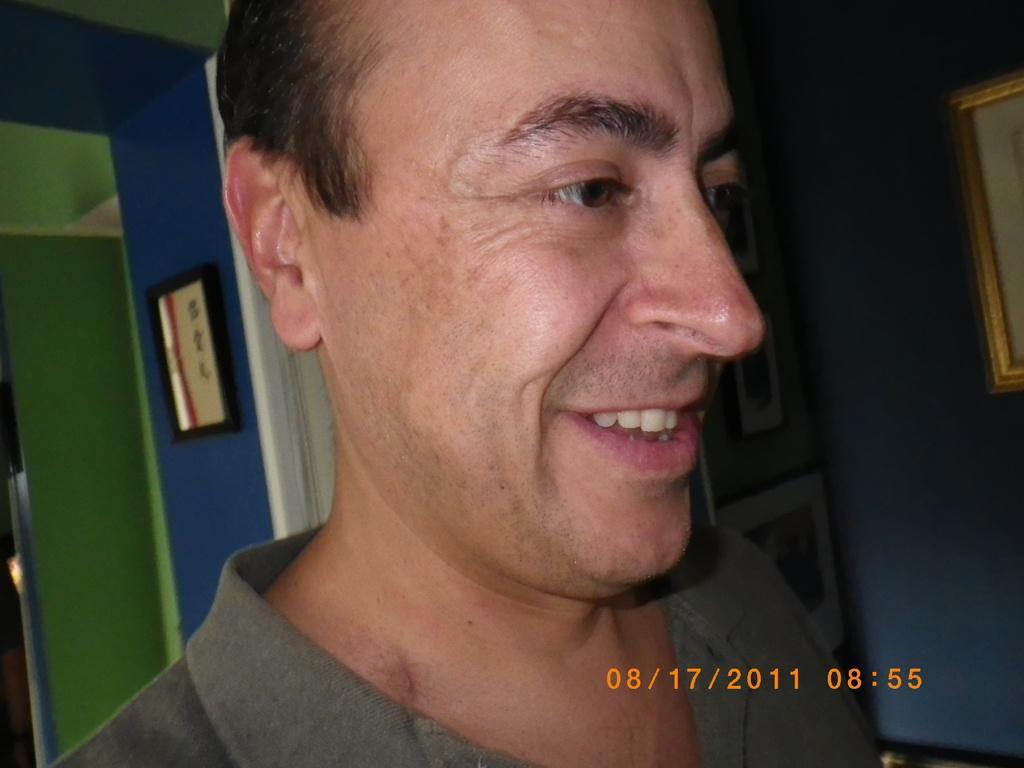How would you summarize this image in a sentence or two? In the image in the center we can see one person smiling,which we can see on his face. In the background there is a wall,roof and photo frames. 